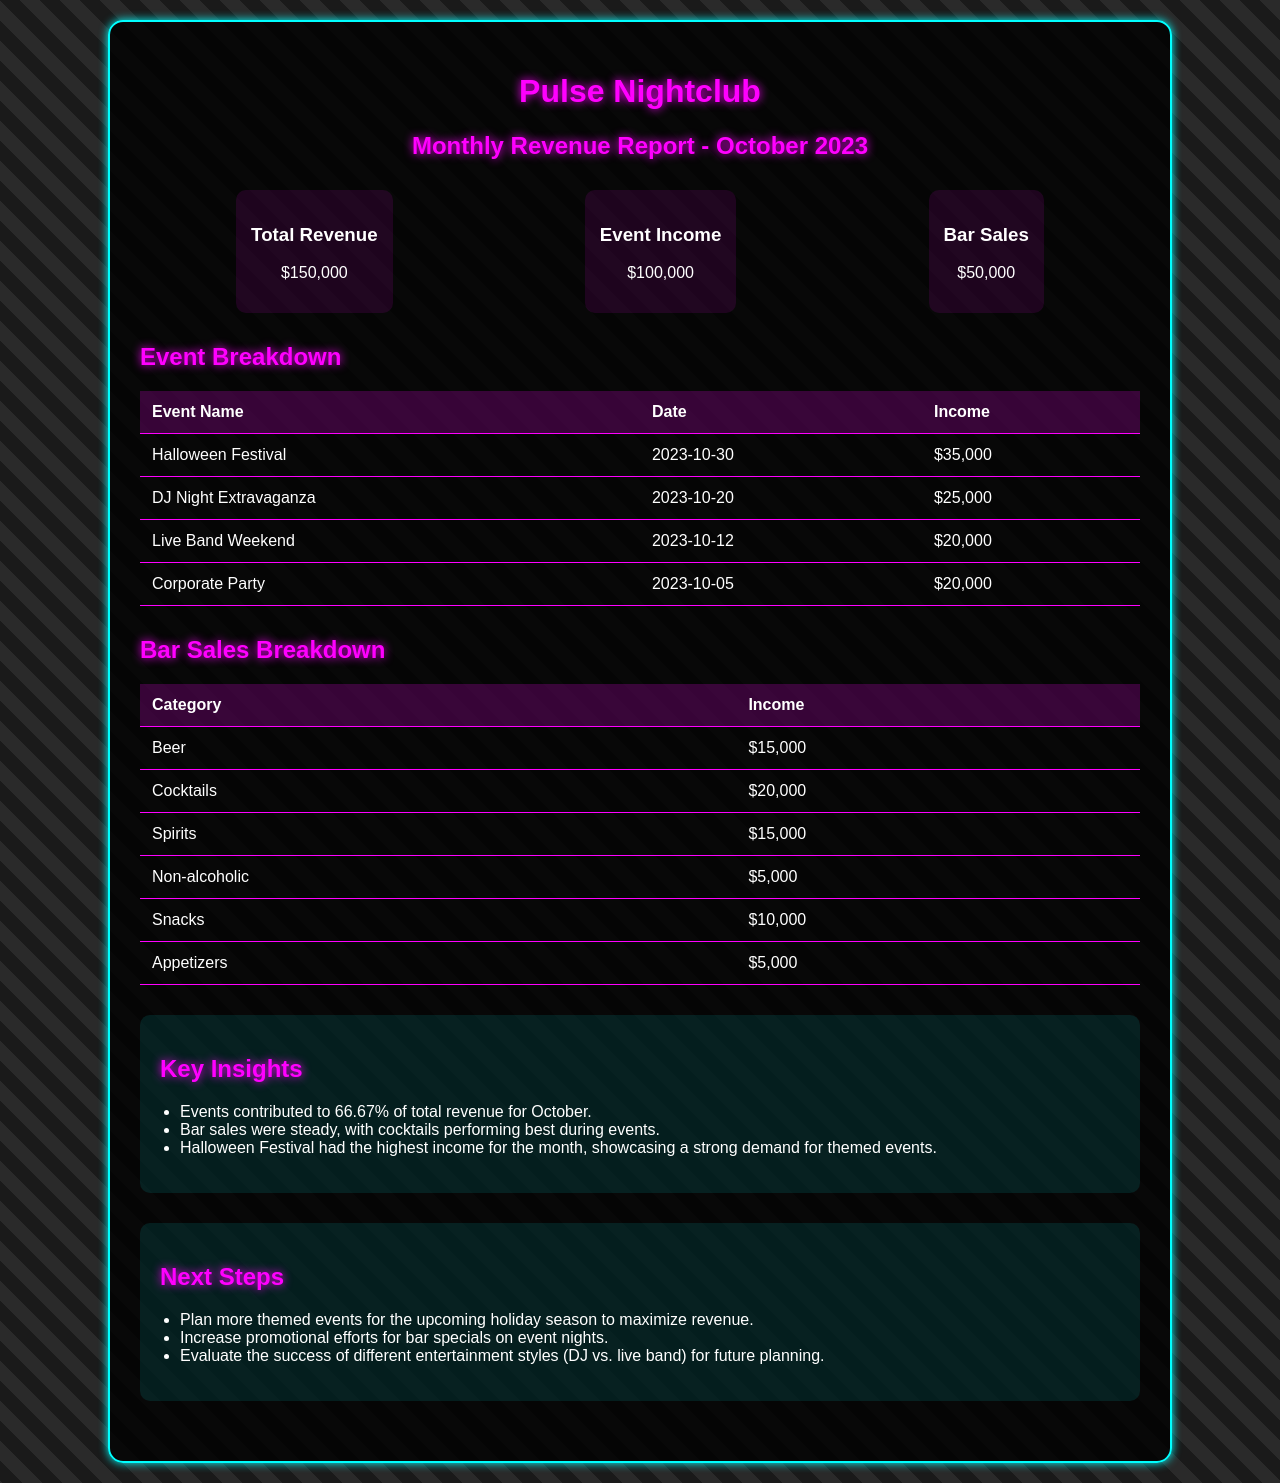What is the total revenue? The total revenue is presented in the revenue summary section of the document, which shows $150,000.
Answer: $150,000 What is the income from the Halloween Festival? The income earned from the Halloween Festival is listed in the event breakdown table, showing $35,000.
Answer: $35,000 How much did bar sales generate? The bar sales income is provided in the revenue summary section and amounts to $50,000.
Answer: $50,000 What type of event generated $25,000? The event breakdown table indicates that the DJ Night Extravaganza generated $25,000.
Answer: DJ Night Extravaganza What percentage of total revenue came from events? The key insight states that events contributed to 66.67% of total revenue for October.
Answer: 66.67% Which category of bar sales generated the highest income? The bar sales breakdown indicates that cocktails generated the highest income at $20,000.
Answer: Cocktails On what date was the Corporate Party held? The event breakdown table lists the date of the Corporate Party as October 5, 2023.
Answer: 2023-10-05 What are the next steps suggested in the report? The next steps outlined in the document include planning more themed events and increasing promotional efforts.
Answer: Plan more themed events What was the total income from the Live Band Weekend? The income from the Live Band Weekend is shown in the event breakdown table as $20,000.
Answer: $20,000 